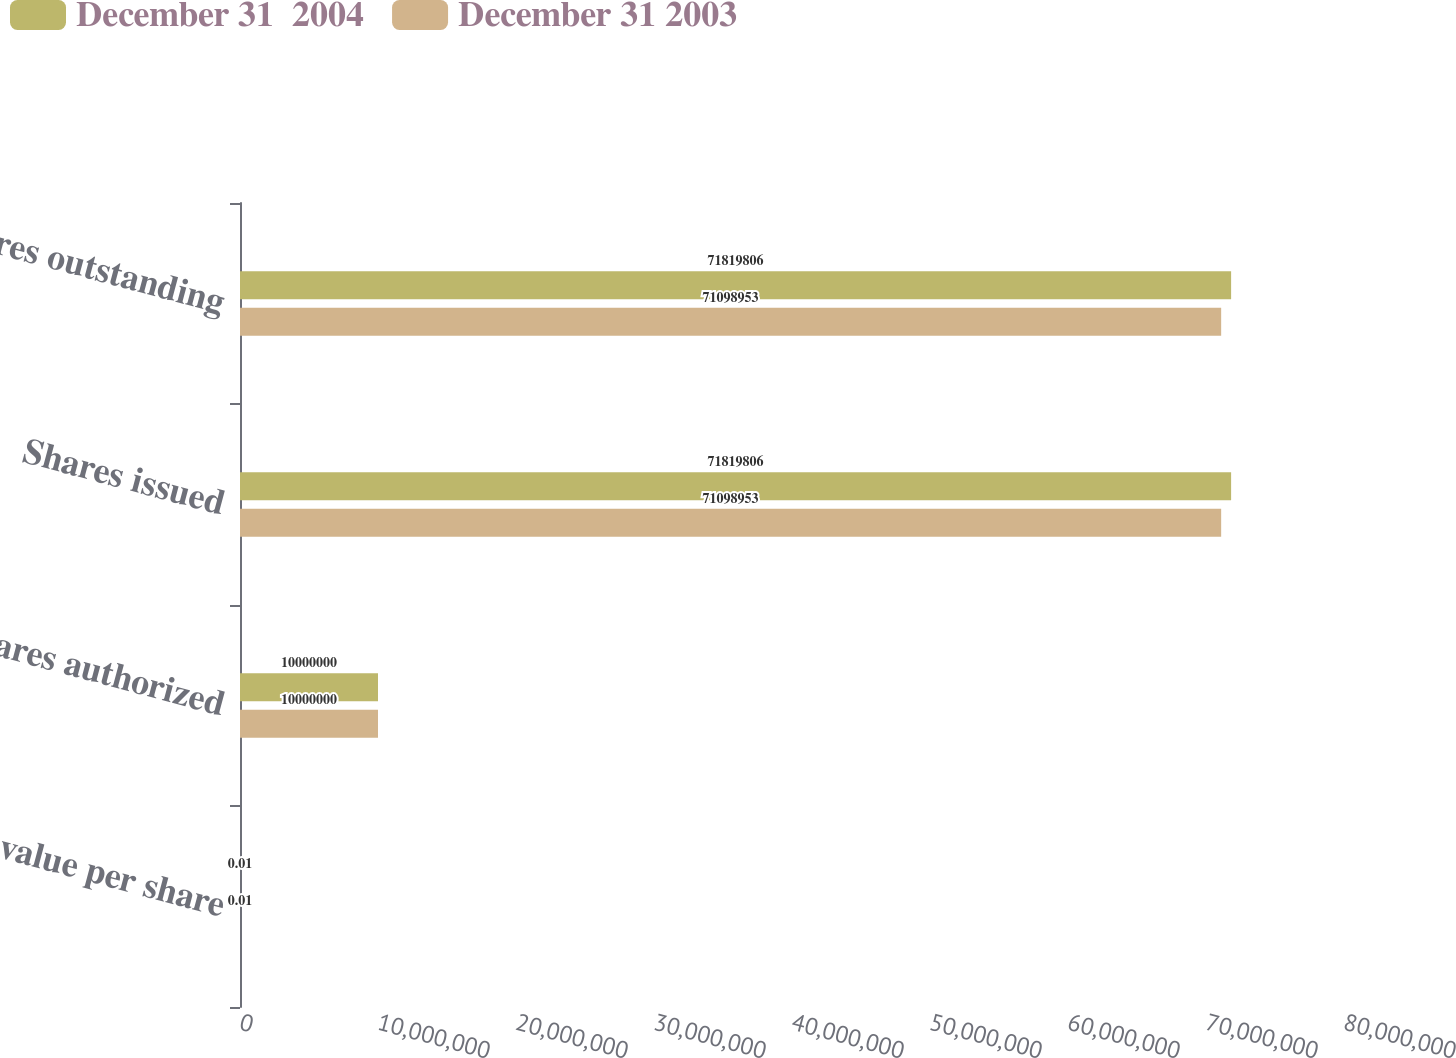Convert chart. <chart><loc_0><loc_0><loc_500><loc_500><stacked_bar_chart><ecel><fcel>Par value per share<fcel>Shares authorized<fcel>Shares issued<fcel>Shares outstanding<nl><fcel>December 31  2004<fcel>0.01<fcel>1e+07<fcel>7.18198e+07<fcel>7.18198e+07<nl><fcel>December 31 2003<fcel>0.01<fcel>1e+07<fcel>7.1099e+07<fcel>7.1099e+07<nl></chart> 